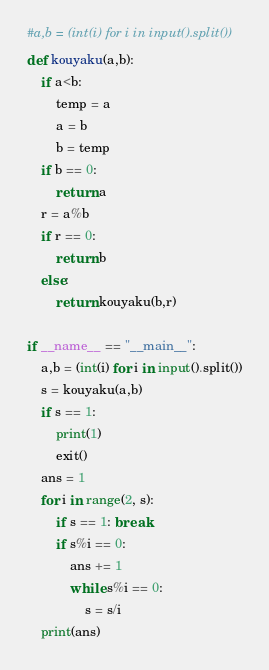<code> <loc_0><loc_0><loc_500><loc_500><_Python_>#a,b = (int(i) for i in input().split())
def kouyaku(a,b):
    if a<b:
        temp = a
        a = b
        b = temp
    if b == 0:
        return a
    r = a%b
    if r == 0:
        return b
    else:
        return kouyaku(b,r)

if __name__ == "__main__":
    a,b = (int(i) for i in input().split())
    s = kouyaku(a,b)
    if s == 1:
        print(1)
        exit()
    ans = 1
    for i in range(2, s):
        if s == 1: break
        if s%i == 0:
            ans += 1
            while s%i == 0:
                s = s/i
    print(ans)</code> 